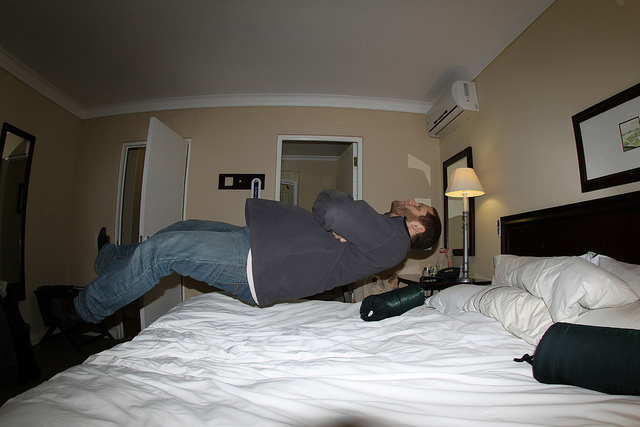Can you tell me something about the setting of this photo? The photo is taken in a plainly decorated hotel room. The room has neutral-toned walls and bedding, a nightstand with a lamp, and a green bottle lying on the bed. A mirror and an open door can be seen in the background. The setting suggests that the person is in a private space where they feel comfortable enough to engage in a playful activity like creating the illusion of floating. 